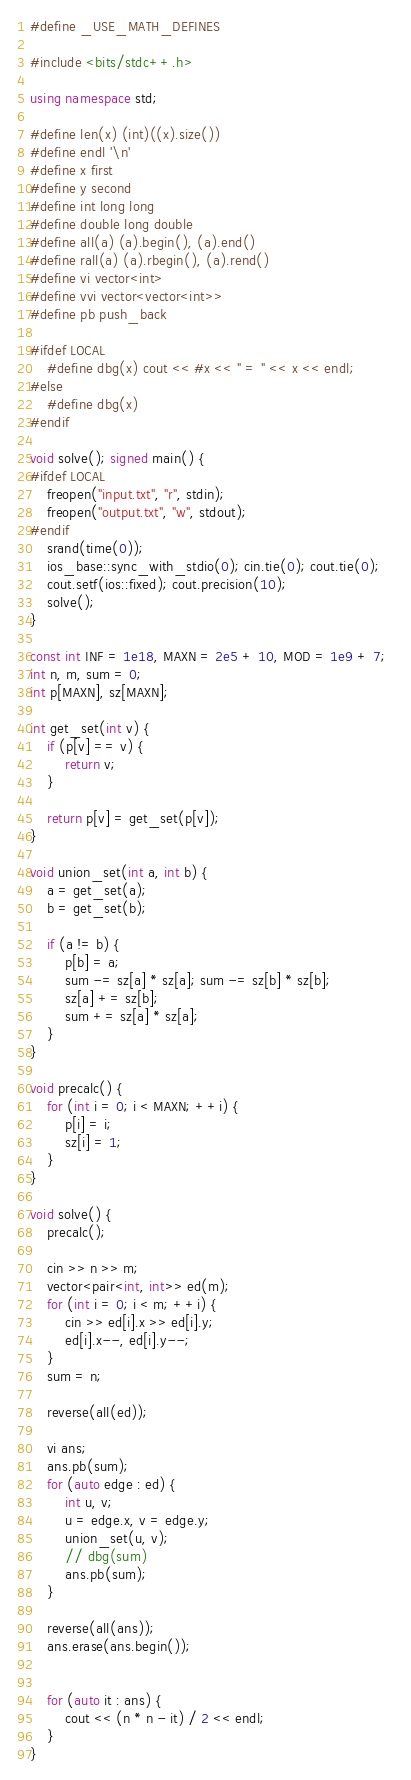<code> <loc_0><loc_0><loc_500><loc_500><_C++_>#define _USE_MATH_DEFINES
 
#include <bits/stdc++.h> 
 
using namespace std;
 
#define len(x) (int)((x).size())
#define endl '\n'
#define x first
#define y second
#define int long long
#define double long double
#define all(a) (a).begin(), (a).end()
#define rall(a) (a).rbegin(), (a).rend()
#define vi vector<int> 
#define vvi vector<vector<int>>
#define pb push_back
 
#ifdef LOCAL
    #define dbg(x) cout << #x << " = " << x << endl;
#else 
    #define dbg(x)
#endif 
 
void solve(); signed main() {
#ifdef LOCAL
    freopen("input.txt", "r", stdin);                                       
    freopen("output.txt", "w", stdout);
#endif
    srand(time(0));
    ios_base::sync_with_stdio(0); cin.tie(0); cout.tie(0);
    cout.setf(ios::fixed); cout.precision(10);
    solve();    
}
 
const int INF = 1e18, MAXN = 2e5 + 10, MOD = 1e9 + 7;
int n, m, sum = 0;
int p[MAXN], sz[MAXN];

int get_set(int v) {
	if (p[v] == v) {
		return v;
	}

	return p[v] = get_set(p[v]);
}

void union_set(int a, int b) {
	a = get_set(a);
	b = get_set(b);

	if (a != b) {
		p[b] = a;
		sum -= sz[a] * sz[a]; sum -= sz[b] * sz[b];
		sz[a] += sz[b];
		sum += sz[a] * sz[a];
	}
}

void precalc() {
	for (int i = 0; i < MAXN; ++i) {
		p[i] = i;
		sz[i] = 1;
	}
}

void solve() {
	precalc();

	cin >> n >> m;
	vector<pair<int, int>> ed(m);
	for (int i = 0; i < m; ++i) {
		cin >> ed[i].x >> ed[i].y;
		ed[i].x--, ed[i].y--;
	}
	sum = n;

	reverse(all(ed));

	vi ans;
	ans.pb(sum);
	for (auto edge : ed) {
		int u, v;
		u = edge.x, v = edge.y;
		union_set(u, v);
		// dbg(sum)
		ans.pb(sum);
	}

	reverse(all(ans));
	ans.erase(ans.begin());
	

	for (auto it : ans) {
		cout << (n * n - it) / 2 << endl;
	}
}
</code> 